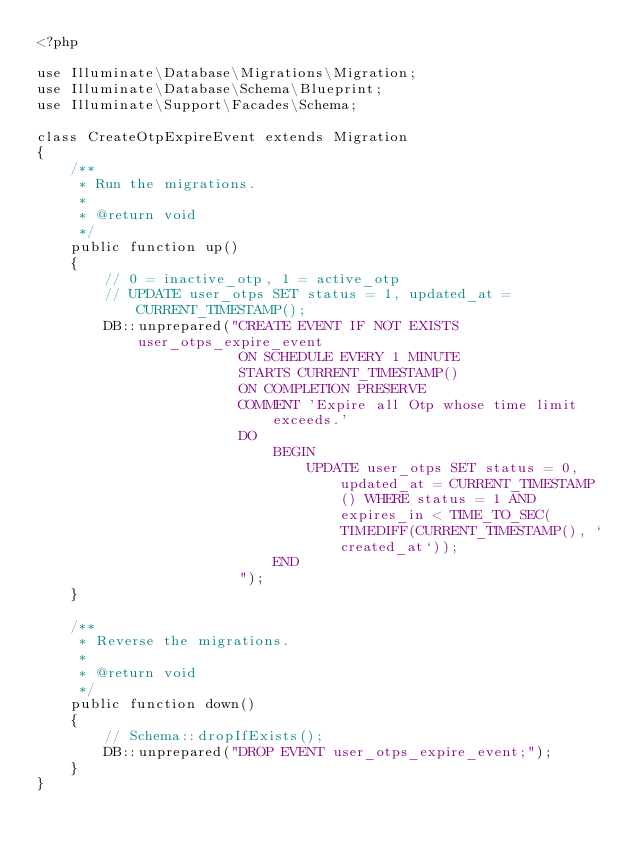<code> <loc_0><loc_0><loc_500><loc_500><_PHP_><?php

use Illuminate\Database\Migrations\Migration;
use Illuminate\Database\Schema\Blueprint;
use Illuminate\Support\Facades\Schema;

class CreateOtpExpireEvent extends Migration
{
    /**
     * Run the migrations.
     *
     * @return void
     */
    public function up()
    {
        // 0 = inactive_otp, 1 = active_otp
        // UPDATE user_otps SET status = 1, updated_at = CURRENT_TIMESTAMP();
        DB::unprepared("CREATE EVENT IF NOT EXISTS user_otps_expire_event
                        ON SCHEDULE EVERY 1 MINUTE
                        STARTS CURRENT_TIMESTAMP()
                        ON COMPLETION PRESERVE
                        COMMENT 'Expire all Otp whose time limit exceeds.'
                        DO
                            BEGIN
                                UPDATE user_otps SET status = 0, updated_at = CURRENT_TIMESTAMP() WHERE status = 1 AND expires_in < TIME_TO_SEC(TIMEDIFF(CURRENT_TIMESTAMP(), `created_at`));
                            END
                        ");
    }

    /**
     * Reverse the migrations.
     *
     * @return void
     */
    public function down()
    {
        // Schema::dropIfExists();
        DB::unprepared("DROP EVENT user_otps_expire_event;");
    }
}
</code> 